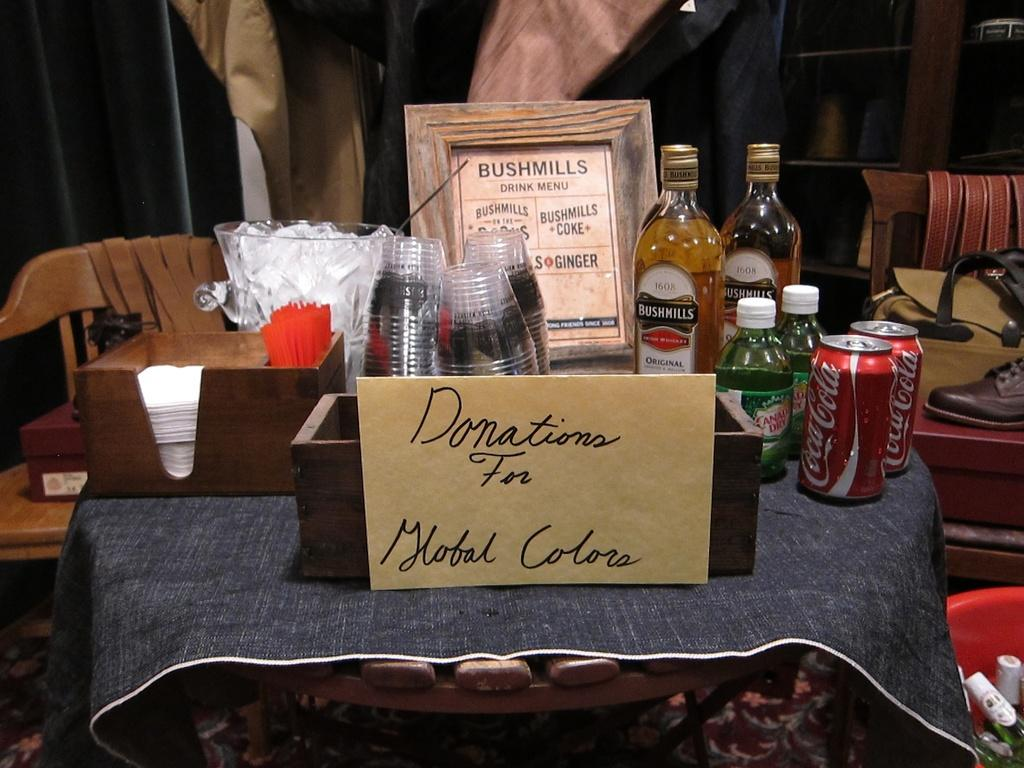What piece of furniture is present in the image? There is a table in the image. What items are placed on the table? Two bottles are placed on the table. What other types of containers are visible in the image? There are cans in the image. What type of drinking vessel is present in the image? There is a glass in the image. What decorative item can be seen in the image? There is a photo frame in the image. How many chairs are visible in the image? There is no mention of chairs in the provided facts, so we cannot determine the number of chairs in the image. 